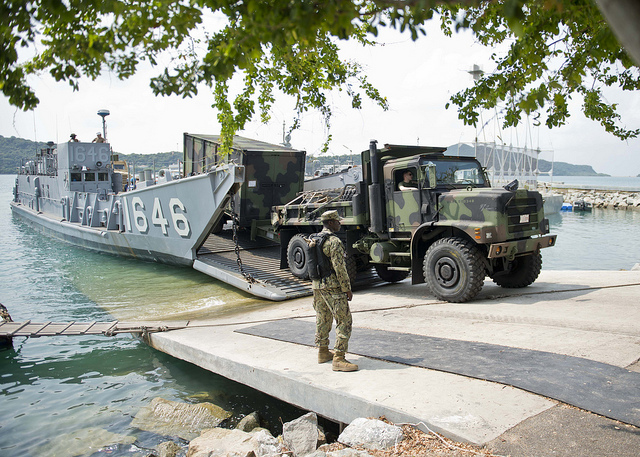Imagine the most creative scenario for the objective of this mission. In the most creative scenario, the military personnel are part of a specialized unit tasked with establishing a covert forward operating base (FOB) on an uninhabited island. They are preparing for a peacekeeping mission that will involve paratrooping supplies to remote, disaster-struck regions that are inaccessible by conventional means. The operation will serve as a launchpad for humanitarian aid missions, but it also doubles as a training ground for secretive and highly coordinated extraction and evacuation drills, preparing for future extraterrestrial expeditions or highly confidential scientific research operations. 